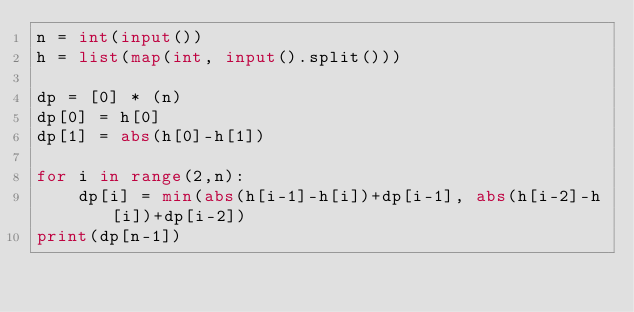<code> <loc_0><loc_0><loc_500><loc_500><_Python_>n = int(input())
h = list(map(int, input().split()))

dp = [0] * (n)
dp[0] = h[0]
dp[1] = abs(h[0]-h[1])

for i in range(2,n):
    dp[i] = min(abs(h[i-1]-h[i])+dp[i-1], abs(h[i-2]-h[i])+dp[i-2])
print(dp[n-1])</code> 